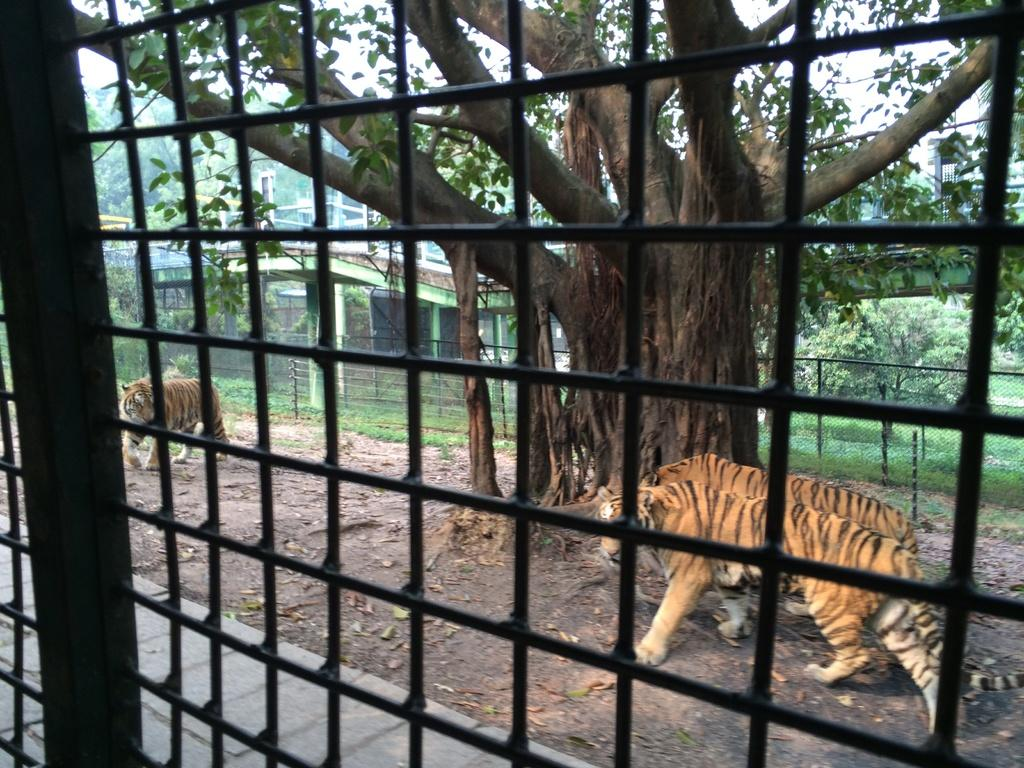What is the main object in the image? There is a grille in the image. What animals are present in the image? There are three tigers on the ground. What is located beside the tigers? There is a tree beside the tigers. What structures can be seen in the background of the image? There is a shed and a fence in the background of the image. What type of vegetation is visible in the background of the image? There is grass and a tree in the background of the image. What part of the natural environment is visible in the background of the image? The sky is visible in the background of the image. How many ghosts are visible in the image? There are no ghosts present in the image. What type of horn can be seen on the tigers in the image? There are no horns present on the tigers in the image. 